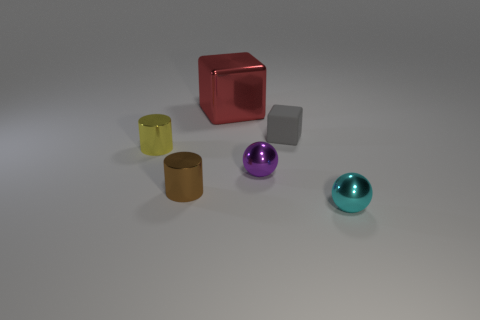Add 3 small matte cubes. How many objects exist? 9 Subtract all cylinders. How many objects are left? 4 Add 4 purple things. How many purple things are left? 5 Add 2 purple spheres. How many purple spheres exist? 3 Subtract 1 yellow cylinders. How many objects are left? 5 Subtract all yellow metal cylinders. Subtract all small brown metallic cylinders. How many objects are left? 4 